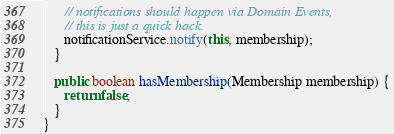Convert code to text. <code><loc_0><loc_0><loc_500><loc_500><_Java_>      // notifications should happen via Domain Events,
      // this is just a quick hack.
      notificationService.notify(this, membership);
   }

   public boolean hasMembership(Membership membership) {
      return false;
   }
}
</code> 